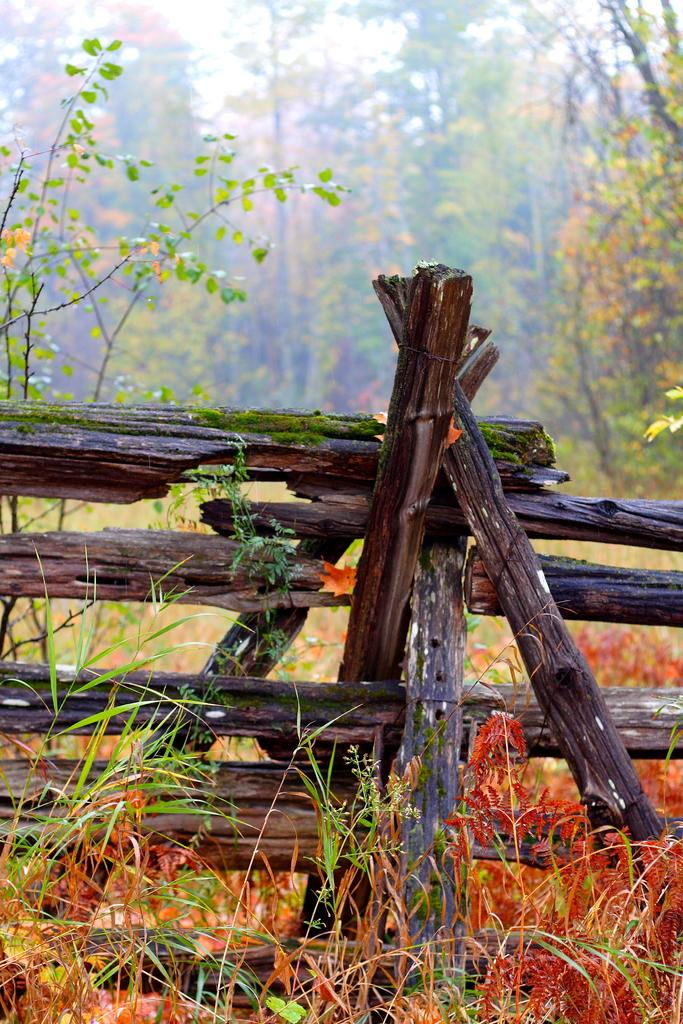What type of vegetation can be seen in the background of the image? There are trees in the background of the image. What type of barrier is present in the image? There is a wooden fence in the image. What other type of vegetation is visible in the image? There are plants in the image. Can you hear the birds crying in the image? There are no birds or any indication of sound in the image, so it is not possible to hear any crying. 